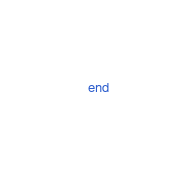Convert code to text. <code><loc_0><loc_0><loc_500><loc_500><_Ruby_>end
</code> 